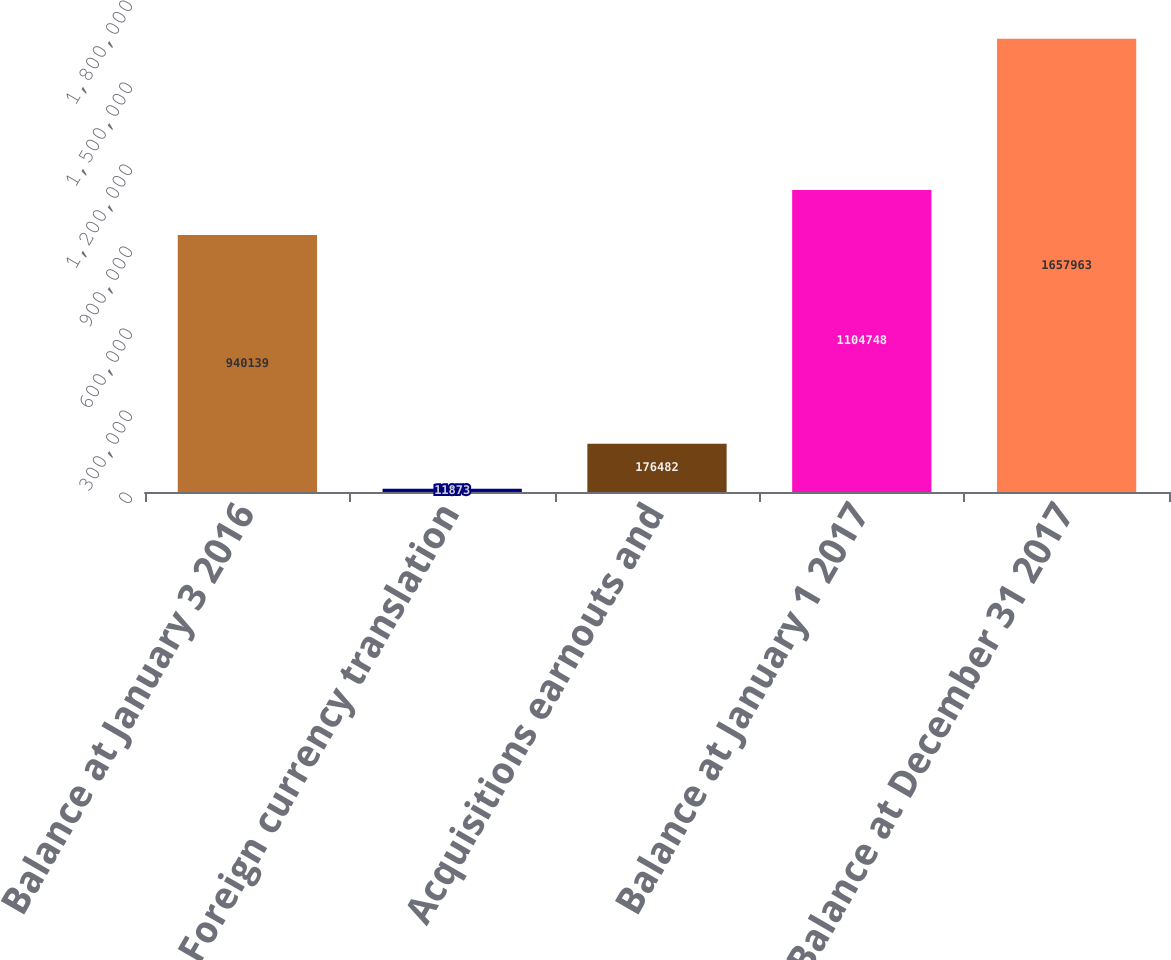Convert chart. <chart><loc_0><loc_0><loc_500><loc_500><bar_chart><fcel>Balance at January 3 2016<fcel>Foreign currency translation<fcel>Acquisitions earnouts and<fcel>Balance at January 1 2017<fcel>Balance at December 31 2017<nl><fcel>940139<fcel>11873<fcel>176482<fcel>1.10475e+06<fcel>1.65796e+06<nl></chart> 